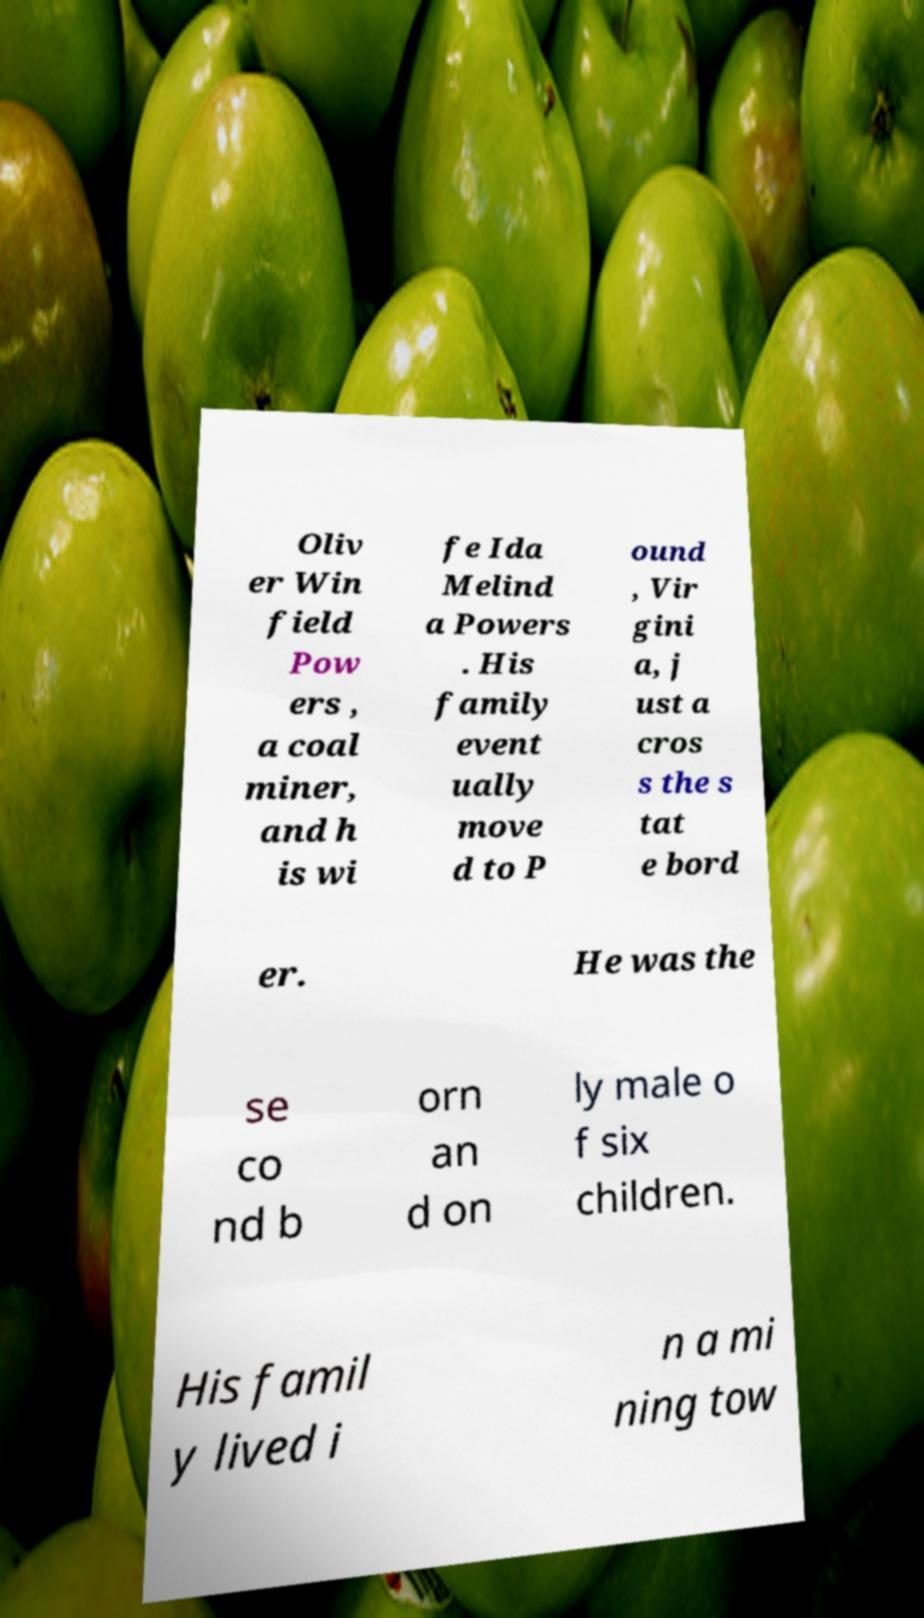I need the written content from this picture converted into text. Can you do that? Oliv er Win field Pow ers , a coal miner, and h is wi fe Ida Melind a Powers . His family event ually move d to P ound , Vir gini a, j ust a cros s the s tat e bord er. He was the se co nd b orn an d on ly male o f six children. His famil y lived i n a mi ning tow 